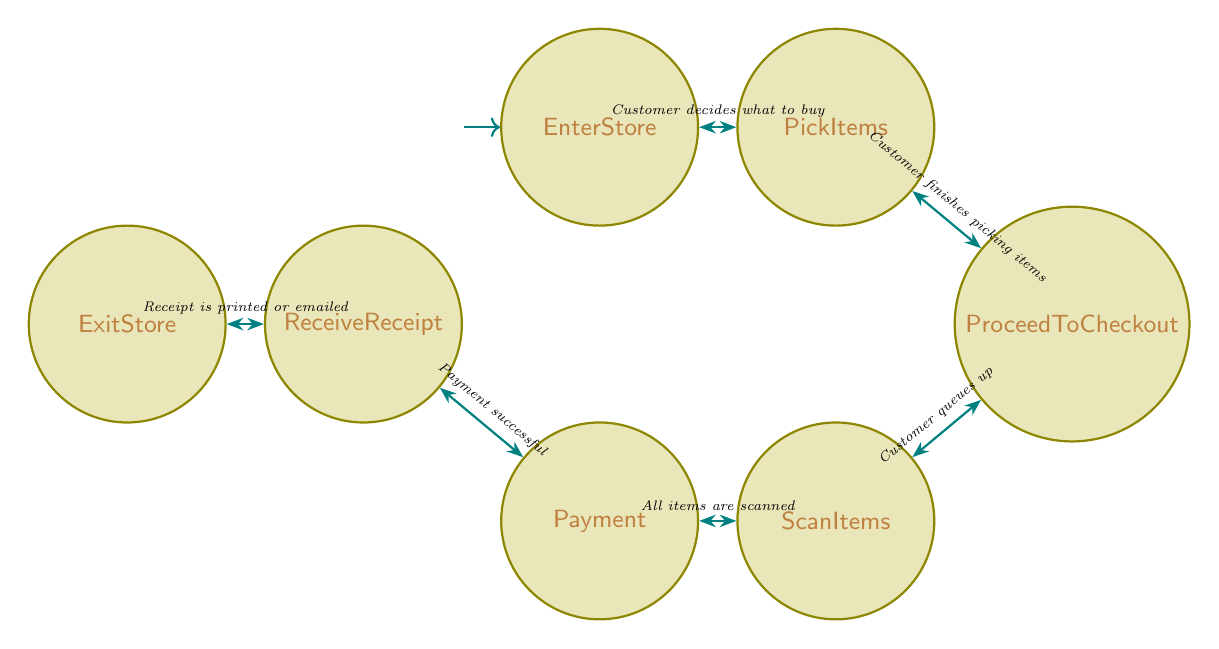What is the initial state of the diagram? The initial state is the first node that represents where the process begins, which is "EnterStore".
Answer: EnterStore How many states are present in the diagram? Each unique state is counted. The states are EnterStore, PickItems, ProceedToCheckout, ScanItems, Payment, ReceiveReceipt, and ExitStore, totaling seven states.
Answer: 7 What triggers the transition from "ScanItems" to "Payment"? The diagram states that the transition from "ScanItems" to "Payment" occurs when "All items are scanned".
Answer: All items are scanned Which state follows "ReceiveReceipt"? The transition rule shows that "ReceiveReceipt" leads directly to "ExitStore" as the next step in the process.
Answer: ExitStore What is the relationship between "PickItems" and "ProceedToCheckout"? The relationship is a directional transition where "PickItems" leads to "ProceedToCheckout" triggered by "Customer finishes picking items".
Answer: Transition What state is reached after "Payment"? The flow from "Payment" leads directly to "ReceiveReceipt" as the next state in the sequence.
Answer: ReceiveReceipt What is the final state in the diagram? The diagram designates the last state that concludes the process, which is "ExitStore".
Answer: ExitStore How many transitions are there in the diagram? Each connection between states is counted as a transition. There are six transitions detailed in the diagram, correlating to each state movement.
Answer: 6 What must happen for a customer to move from "ProceedToCheckout"? The customer needs to queue up at the checkout counter or self-checkout, which triggers the transition from "ProceedToCheckout" to "ScanItems".
Answer: Customer queues up 